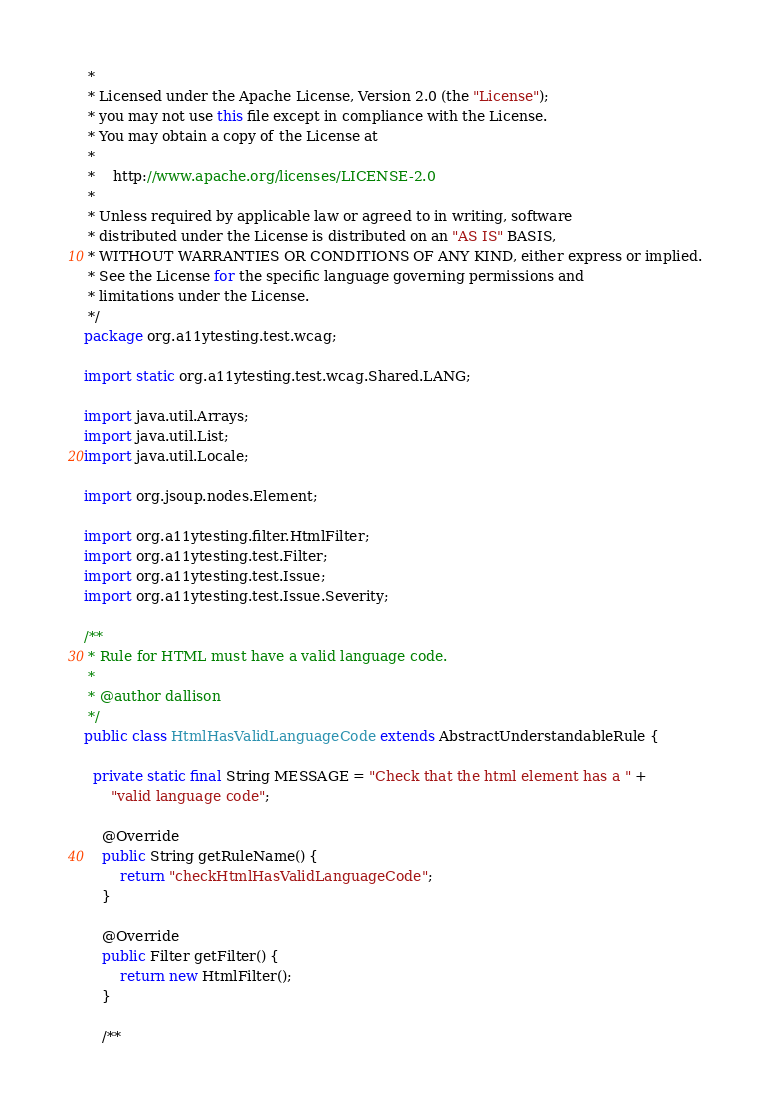<code> <loc_0><loc_0><loc_500><loc_500><_Java_> * 
 * Licensed under the Apache License, Version 2.0 (the "License");
 * you may not use this file except in compliance with the License.
 * You may obtain a copy of the License at
 * 
 *    http://www.apache.org/licenses/LICENSE-2.0
 *    
 * Unless required by applicable law or agreed to in writing, software
 * distributed under the License is distributed on an "AS IS" BASIS,
 * WITHOUT WARRANTIES OR CONDITIONS OF ANY KIND, either express or implied.
 * See the License for the specific language governing permissions and
 * limitations under the License.
 */
package org.a11ytesting.test.wcag;

import static org.a11ytesting.test.wcag.Shared.LANG;

import java.util.Arrays;
import java.util.List;
import java.util.Locale;

import org.jsoup.nodes.Element;

import org.a11ytesting.filter.HtmlFilter;
import org.a11ytesting.test.Filter;
import org.a11ytesting.test.Issue;
import org.a11ytesting.test.Issue.Severity;

/**
 * Rule for HTML must have a valid language code.
 * 
 * @author dallison
 */
public class HtmlHasValidLanguageCode extends AbstractUnderstandableRule {

  private static final String MESSAGE = "Check that the html element has a " +
      "valid language code";

	@Override
	public String getRuleName() {
		return "checkHtmlHasValidLanguageCode";
	}

	@Override
	public Filter getFilter() {
		return new HtmlFilter();
	}

	/**</code> 